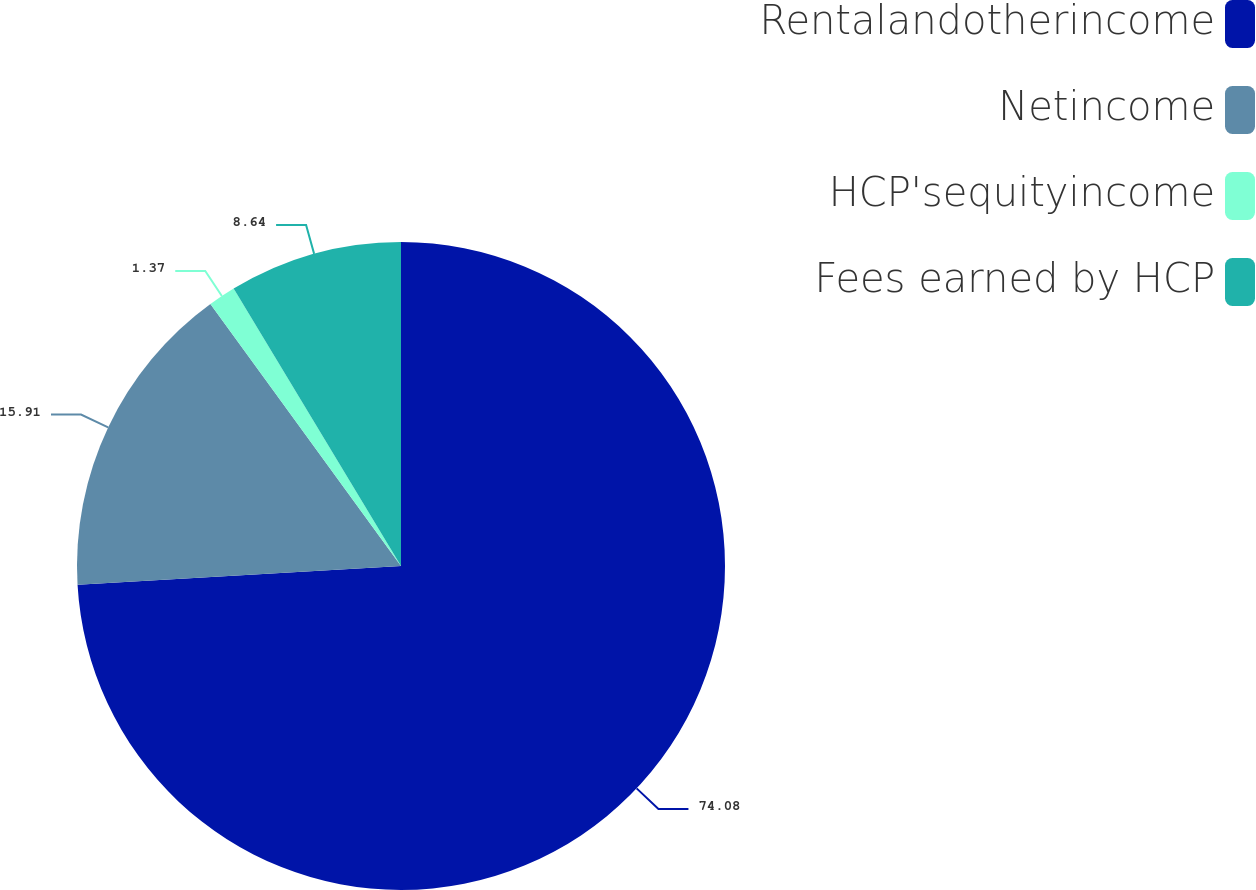Convert chart to OTSL. <chart><loc_0><loc_0><loc_500><loc_500><pie_chart><fcel>Rentalandotherincome<fcel>Netincome<fcel>HCP'sequityincome<fcel>Fees earned by HCP<nl><fcel>74.08%<fcel>15.91%<fcel>1.37%<fcel>8.64%<nl></chart> 